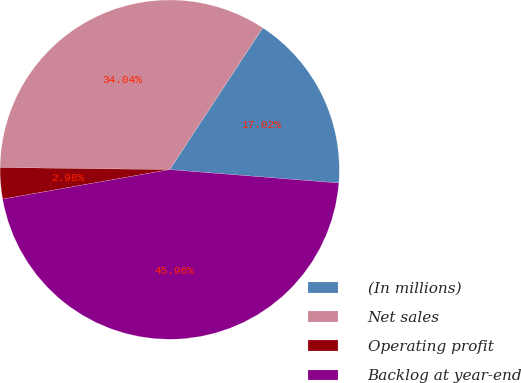Convert chart. <chart><loc_0><loc_0><loc_500><loc_500><pie_chart><fcel>(In millions)<fcel>Net sales<fcel>Operating profit<fcel>Backlog at year-end<nl><fcel>17.02%<fcel>34.04%<fcel>2.98%<fcel>45.96%<nl></chart> 